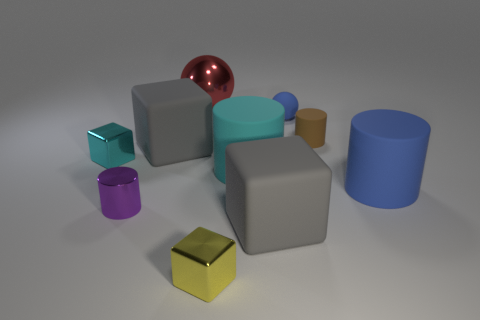Subtract all cylinders. How many objects are left? 6 Add 6 large blue matte cylinders. How many large blue matte cylinders are left? 7 Add 4 tiny metallic cylinders. How many tiny metallic cylinders exist? 5 Subtract 1 red spheres. How many objects are left? 9 Subtract all large cylinders. Subtract all big blue matte cylinders. How many objects are left? 7 